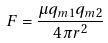Convert formula to latex. <formula><loc_0><loc_0><loc_500><loc_500>F = { \frac { \mu q _ { m 1 } q _ { m 2 } } { 4 \pi r ^ { 2 } } }</formula> 